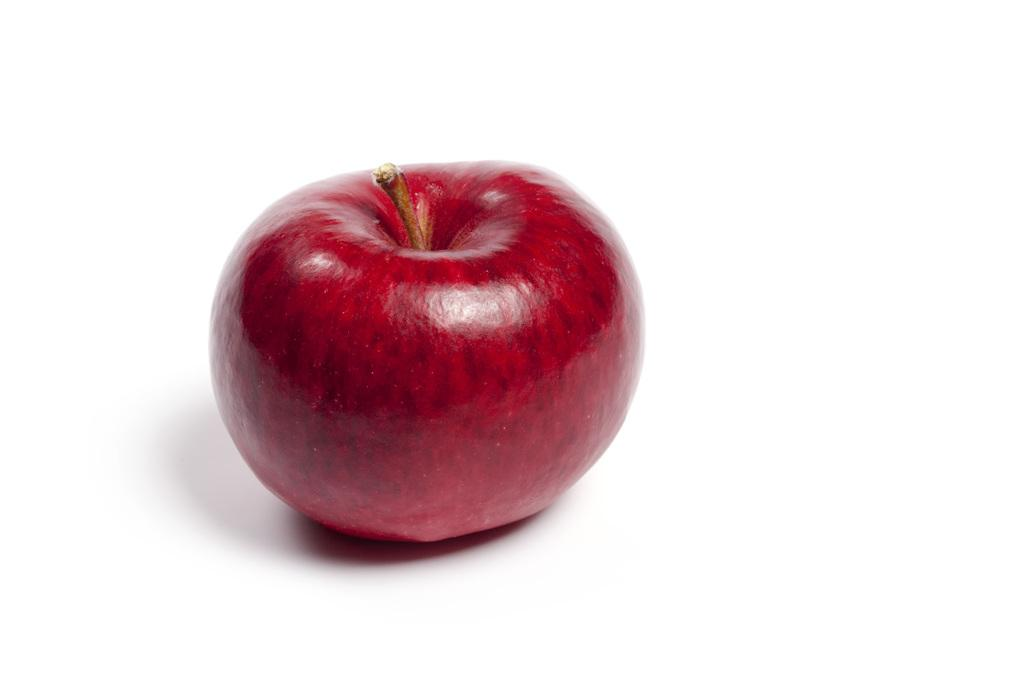What is the main object in the image? There is an apple in the image. What color is the apple? The apple is red in color. What is the surface on which the apple is placed? The apple is placed on a white surface. How does the apple express regret in the image? The apple does not express regret in the image, as it is an inanimate object and cannot experience emotions. 